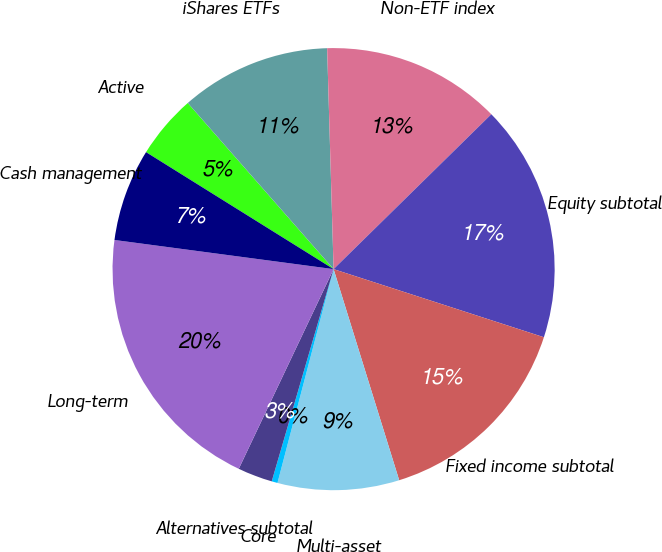<chart> <loc_0><loc_0><loc_500><loc_500><pie_chart><fcel>Active<fcel>iShares ETFs<fcel>Non-ETF index<fcel>Equity subtotal<fcel>Fixed income subtotal<fcel>Multi-asset<fcel>Core<fcel>Alternatives subtotal<fcel>Long-term<fcel>Cash management<nl><fcel>4.66%<fcel>11.0%<fcel>13.11%<fcel>17.34%<fcel>15.22%<fcel>8.88%<fcel>0.43%<fcel>2.54%<fcel>20.05%<fcel>6.77%<nl></chart> 